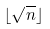<formula> <loc_0><loc_0><loc_500><loc_500>\lfloor \sqrt { n } \rfloor</formula> 